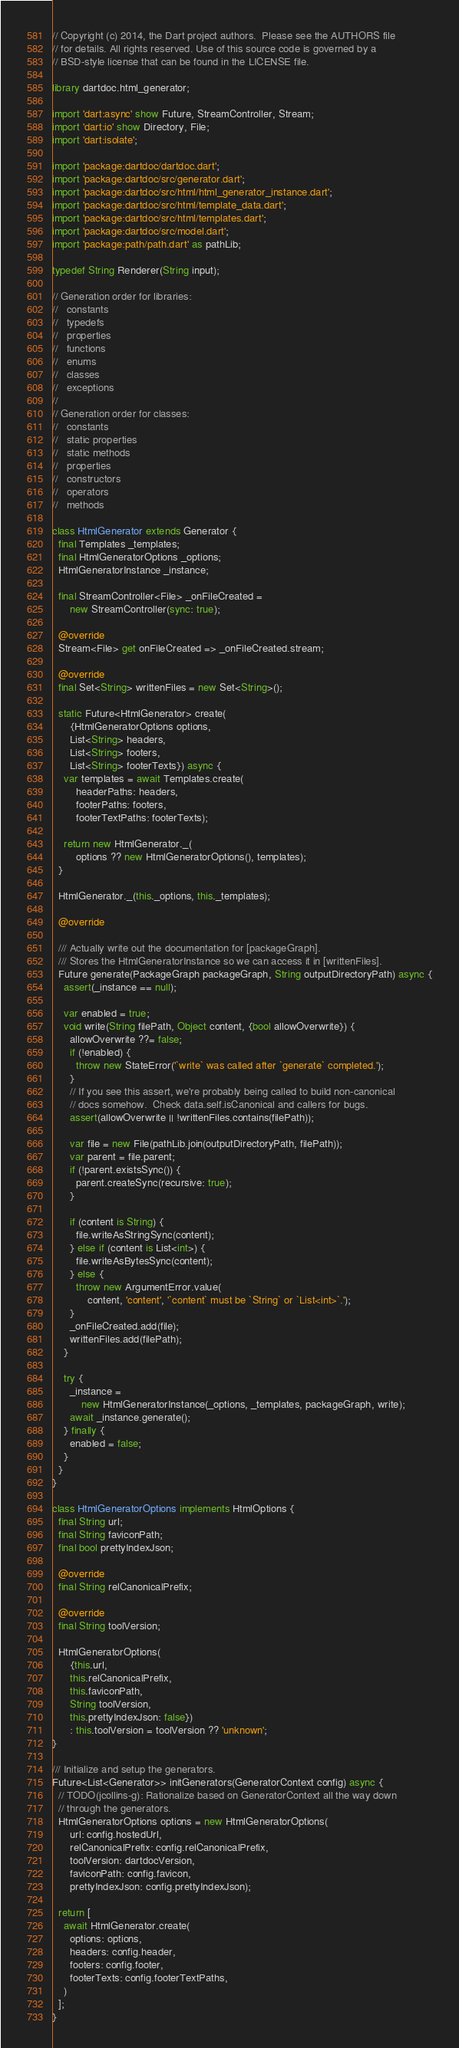<code> <loc_0><loc_0><loc_500><loc_500><_Dart_>// Copyright (c) 2014, the Dart project authors.  Please see the AUTHORS file
// for details. All rights reserved. Use of this source code is governed by a
// BSD-style license that can be found in the LICENSE file.

library dartdoc.html_generator;

import 'dart:async' show Future, StreamController, Stream;
import 'dart:io' show Directory, File;
import 'dart:isolate';

import 'package:dartdoc/dartdoc.dart';
import 'package:dartdoc/src/generator.dart';
import 'package:dartdoc/src/html/html_generator_instance.dart';
import 'package:dartdoc/src/html/template_data.dart';
import 'package:dartdoc/src/html/templates.dart';
import 'package:dartdoc/src/model.dart';
import 'package:path/path.dart' as pathLib;

typedef String Renderer(String input);

// Generation order for libraries:
//   constants
//   typedefs
//   properties
//   functions
//   enums
//   classes
//   exceptions
//
// Generation order for classes:
//   constants
//   static properties
//   static methods
//   properties
//   constructors
//   operators
//   methods

class HtmlGenerator extends Generator {
  final Templates _templates;
  final HtmlGeneratorOptions _options;
  HtmlGeneratorInstance _instance;

  final StreamController<File> _onFileCreated =
      new StreamController(sync: true);

  @override
  Stream<File> get onFileCreated => _onFileCreated.stream;

  @override
  final Set<String> writtenFiles = new Set<String>();

  static Future<HtmlGenerator> create(
      {HtmlGeneratorOptions options,
      List<String> headers,
      List<String> footers,
      List<String> footerTexts}) async {
    var templates = await Templates.create(
        headerPaths: headers,
        footerPaths: footers,
        footerTextPaths: footerTexts);

    return new HtmlGenerator._(
        options ?? new HtmlGeneratorOptions(), templates);
  }

  HtmlGenerator._(this._options, this._templates);

  @override

  /// Actually write out the documentation for [packageGraph].
  /// Stores the HtmlGeneratorInstance so we can access it in [writtenFiles].
  Future generate(PackageGraph packageGraph, String outputDirectoryPath) async {
    assert(_instance == null);

    var enabled = true;
    void write(String filePath, Object content, {bool allowOverwrite}) {
      allowOverwrite ??= false;
      if (!enabled) {
        throw new StateError('`write` was called after `generate` completed.');
      }
      // If you see this assert, we're probably being called to build non-canonical
      // docs somehow.  Check data.self.isCanonical and callers for bugs.
      assert(allowOverwrite || !writtenFiles.contains(filePath));

      var file = new File(pathLib.join(outputDirectoryPath, filePath));
      var parent = file.parent;
      if (!parent.existsSync()) {
        parent.createSync(recursive: true);
      }

      if (content is String) {
        file.writeAsStringSync(content);
      } else if (content is List<int>) {
        file.writeAsBytesSync(content);
      } else {
        throw new ArgumentError.value(
            content, 'content', '`content` must be `String` or `List<int>`.');
      }
      _onFileCreated.add(file);
      writtenFiles.add(filePath);
    }

    try {
      _instance =
          new HtmlGeneratorInstance(_options, _templates, packageGraph, write);
      await _instance.generate();
    } finally {
      enabled = false;
    }
  }
}

class HtmlGeneratorOptions implements HtmlOptions {
  final String url;
  final String faviconPath;
  final bool prettyIndexJson;

  @override
  final String relCanonicalPrefix;

  @override
  final String toolVersion;

  HtmlGeneratorOptions(
      {this.url,
      this.relCanonicalPrefix,
      this.faviconPath,
      String toolVersion,
      this.prettyIndexJson: false})
      : this.toolVersion = toolVersion ?? 'unknown';
}

/// Initialize and setup the generators.
Future<List<Generator>> initGenerators(GeneratorContext config) async {
  // TODO(jcollins-g): Rationalize based on GeneratorContext all the way down
  // through the generators.
  HtmlGeneratorOptions options = new HtmlGeneratorOptions(
      url: config.hostedUrl,
      relCanonicalPrefix: config.relCanonicalPrefix,
      toolVersion: dartdocVersion,
      faviconPath: config.favicon,
      prettyIndexJson: config.prettyIndexJson);

  return [
    await HtmlGenerator.create(
      options: options,
      headers: config.header,
      footers: config.footer,
      footerTexts: config.footerTextPaths,
    )
  ];
}
</code> 